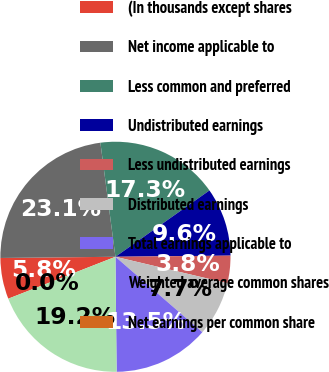<chart> <loc_0><loc_0><loc_500><loc_500><pie_chart><fcel>(In thousands except shares<fcel>Net income applicable to<fcel>Less common and preferred<fcel>Undistributed earnings<fcel>Less undistributed earnings<fcel>Distributed earnings<fcel>Total earnings applicable to<fcel>Weighted average common shares<fcel>Net earnings per common share<nl><fcel>5.77%<fcel>23.08%<fcel>17.31%<fcel>9.62%<fcel>3.85%<fcel>7.69%<fcel>13.46%<fcel>19.23%<fcel>0.0%<nl></chart> 